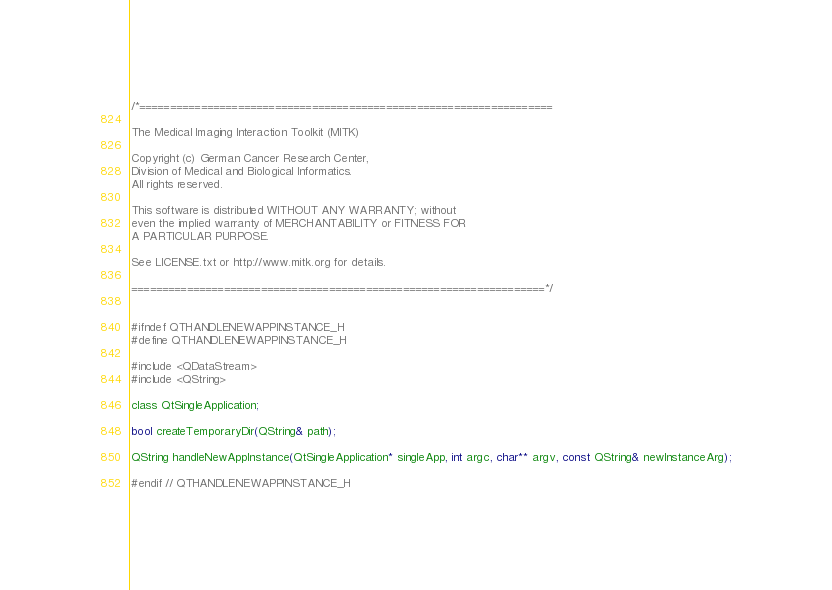Convert code to text. <code><loc_0><loc_0><loc_500><loc_500><_C_>/*===================================================================

The Medical Imaging Interaction Toolkit (MITK)

Copyright (c) German Cancer Research Center,
Division of Medical and Biological Informatics.
All rights reserved.

This software is distributed WITHOUT ANY WARRANTY; without
even the implied warranty of MERCHANTABILITY or FITNESS FOR
A PARTICULAR PURPOSE.

See LICENSE.txt or http://www.mitk.org for details.

===================================================================*/


#ifndef QTHANDLENEWAPPINSTANCE_H
#define QTHANDLENEWAPPINSTANCE_H

#include <QDataStream>
#include <QString>

class QtSingleApplication;

bool createTemporaryDir(QString& path);

QString handleNewAppInstance(QtSingleApplication* singleApp, int argc, char** argv, const QString& newInstanceArg);

#endif // QTHANDLENEWAPPINSTANCE_H
</code> 